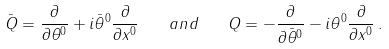Convert formula to latex. <formula><loc_0><loc_0><loc_500><loc_500>\bar { Q } = \frac { \partial } { \partial \theta ^ { 0 } } + i \bar { \theta } ^ { 0 } \frac { \partial } { \partial x ^ { 0 } } \quad a n d \quad Q = - \frac { \partial } { \partial \bar { \theta } ^ { 0 } } - i \theta ^ { 0 } \frac { \partial } { \partial x ^ { 0 } } \, .</formula> 